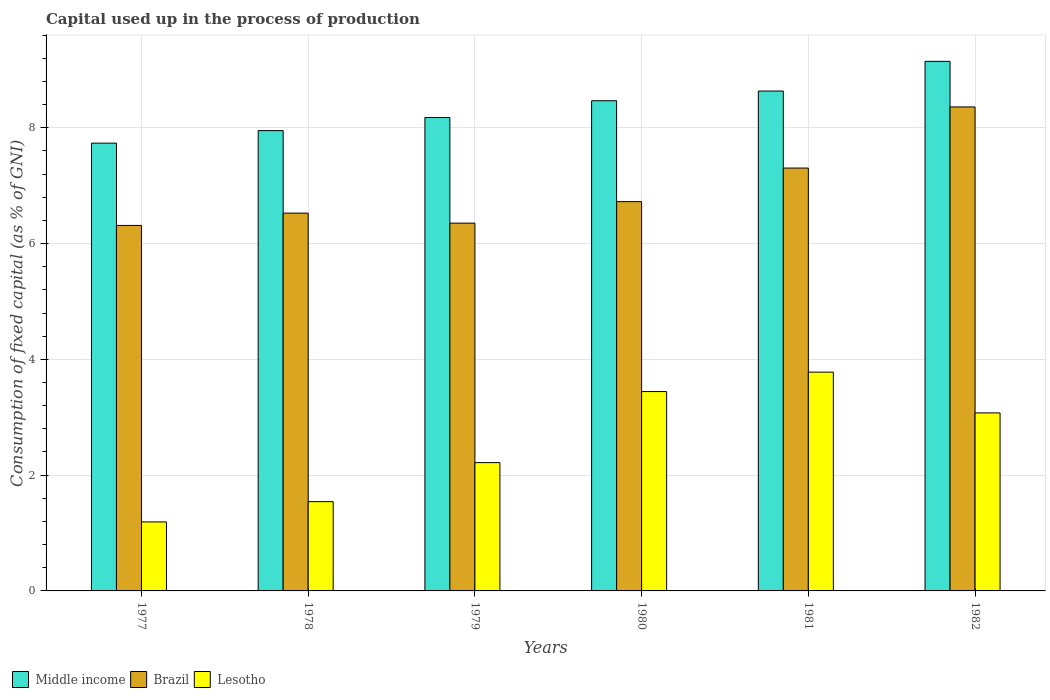How many different coloured bars are there?
Your response must be concise. 3. Are the number of bars per tick equal to the number of legend labels?
Ensure brevity in your answer.  Yes. How many bars are there on the 3rd tick from the right?
Offer a very short reply. 3. What is the label of the 1st group of bars from the left?
Give a very brief answer. 1977. What is the capital used up in the process of production in Lesotho in 1978?
Provide a short and direct response. 1.54. Across all years, what is the maximum capital used up in the process of production in Brazil?
Your answer should be very brief. 8.36. Across all years, what is the minimum capital used up in the process of production in Lesotho?
Keep it short and to the point. 1.19. In which year was the capital used up in the process of production in Brazil maximum?
Provide a short and direct response. 1982. In which year was the capital used up in the process of production in Brazil minimum?
Your answer should be very brief. 1977. What is the total capital used up in the process of production in Lesotho in the graph?
Provide a succinct answer. 15.25. What is the difference between the capital used up in the process of production in Middle income in 1977 and that in 1981?
Your answer should be very brief. -0.9. What is the difference between the capital used up in the process of production in Middle income in 1978 and the capital used up in the process of production in Brazil in 1980?
Give a very brief answer. 1.23. What is the average capital used up in the process of production in Brazil per year?
Keep it short and to the point. 6.93. In the year 1982, what is the difference between the capital used up in the process of production in Middle income and capital used up in the process of production in Lesotho?
Ensure brevity in your answer.  6.07. In how many years, is the capital used up in the process of production in Lesotho greater than 0.4 %?
Your response must be concise. 6. What is the ratio of the capital used up in the process of production in Brazil in 1980 to that in 1982?
Provide a short and direct response. 0.8. Is the difference between the capital used up in the process of production in Middle income in 1977 and 1981 greater than the difference between the capital used up in the process of production in Lesotho in 1977 and 1981?
Ensure brevity in your answer.  Yes. What is the difference between the highest and the second highest capital used up in the process of production in Brazil?
Your response must be concise. 1.06. What is the difference between the highest and the lowest capital used up in the process of production in Brazil?
Make the answer very short. 2.05. Is the sum of the capital used up in the process of production in Lesotho in 1977 and 1978 greater than the maximum capital used up in the process of production in Brazil across all years?
Ensure brevity in your answer.  No. What does the 2nd bar from the left in 1978 represents?
Give a very brief answer. Brazil. What does the 2nd bar from the right in 1981 represents?
Your answer should be compact. Brazil. Is it the case that in every year, the sum of the capital used up in the process of production in Brazil and capital used up in the process of production in Middle income is greater than the capital used up in the process of production in Lesotho?
Make the answer very short. Yes. How many bars are there?
Offer a very short reply. 18. Are all the bars in the graph horizontal?
Keep it short and to the point. No. How many years are there in the graph?
Make the answer very short. 6. What is the difference between two consecutive major ticks on the Y-axis?
Offer a terse response. 2. Does the graph contain any zero values?
Your response must be concise. No. Does the graph contain grids?
Your response must be concise. Yes. Where does the legend appear in the graph?
Your response must be concise. Bottom left. What is the title of the graph?
Ensure brevity in your answer.  Capital used up in the process of production. Does "Kuwait" appear as one of the legend labels in the graph?
Provide a succinct answer. No. What is the label or title of the X-axis?
Your answer should be very brief. Years. What is the label or title of the Y-axis?
Provide a succinct answer. Consumption of fixed capital (as % of GNI). What is the Consumption of fixed capital (as % of GNI) of Middle income in 1977?
Make the answer very short. 7.73. What is the Consumption of fixed capital (as % of GNI) in Brazil in 1977?
Offer a very short reply. 6.31. What is the Consumption of fixed capital (as % of GNI) in Lesotho in 1977?
Ensure brevity in your answer.  1.19. What is the Consumption of fixed capital (as % of GNI) in Middle income in 1978?
Your answer should be compact. 7.95. What is the Consumption of fixed capital (as % of GNI) in Brazil in 1978?
Offer a very short reply. 6.53. What is the Consumption of fixed capital (as % of GNI) of Lesotho in 1978?
Your response must be concise. 1.54. What is the Consumption of fixed capital (as % of GNI) in Middle income in 1979?
Make the answer very short. 8.18. What is the Consumption of fixed capital (as % of GNI) of Brazil in 1979?
Your response must be concise. 6.35. What is the Consumption of fixed capital (as % of GNI) in Lesotho in 1979?
Offer a terse response. 2.22. What is the Consumption of fixed capital (as % of GNI) of Middle income in 1980?
Your response must be concise. 8.47. What is the Consumption of fixed capital (as % of GNI) in Brazil in 1980?
Keep it short and to the point. 6.72. What is the Consumption of fixed capital (as % of GNI) of Lesotho in 1980?
Provide a succinct answer. 3.44. What is the Consumption of fixed capital (as % of GNI) of Middle income in 1981?
Offer a terse response. 8.63. What is the Consumption of fixed capital (as % of GNI) in Brazil in 1981?
Offer a very short reply. 7.3. What is the Consumption of fixed capital (as % of GNI) of Lesotho in 1981?
Offer a terse response. 3.78. What is the Consumption of fixed capital (as % of GNI) in Middle income in 1982?
Your answer should be very brief. 9.15. What is the Consumption of fixed capital (as % of GNI) of Brazil in 1982?
Make the answer very short. 8.36. What is the Consumption of fixed capital (as % of GNI) in Lesotho in 1982?
Your answer should be compact. 3.08. Across all years, what is the maximum Consumption of fixed capital (as % of GNI) in Middle income?
Make the answer very short. 9.15. Across all years, what is the maximum Consumption of fixed capital (as % of GNI) in Brazil?
Provide a succinct answer. 8.36. Across all years, what is the maximum Consumption of fixed capital (as % of GNI) in Lesotho?
Your response must be concise. 3.78. Across all years, what is the minimum Consumption of fixed capital (as % of GNI) in Middle income?
Provide a succinct answer. 7.73. Across all years, what is the minimum Consumption of fixed capital (as % of GNI) in Brazil?
Your answer should be compact. 6.31. Across all years, what is the minimum Consumption of fixed capital (as % of GNI) of Lesotho?
Keep it short and to the point. 1.19. What is the total Consumption of fixed capital (as % of GNI) in Middle income in the graph?
Offer a very short reply. 50.11. What is the total Consumption of fixed capital (as % of GNI) of Brazil in the graph?
Offer a terse response. 41.58. What is the total Consumption of fixed capital (as % of GNI) of Lesotho in the graph?
Make the answer very short. 15.25. What is the difference between the Consumption of fixed capital (as % of GNI) of Middle income in 1977 and that in 1978?
Offer a very short reply. -0.22. What is the difference between the Consumption of fixed capital (as % of GNI) of Brazil in 1977 and that in 1978?
Make the answer very short. -0.21. What is the difference between the Consumption of fixed capital (as % of GNI) in Lesotho in 1977 and that in 1978?
Your answer should be compact. -0.35. What is the difference between the Consumption of fixed capital (as % of GNI) of Middle income in 1977 and that in 1979?
Your answer should be compact. -0.44. What is the difference between the Consumption of fixed capital (as % of GNI) of Brazil in 1977 and that in 1979?
Your answer should be very brief. -0.04. What is the difference between the Consumption of fixed capital (as % of GNI) in Lesotho in 1977 and that in 1979?
Your answer should be very brief. -1.02. What is the difference between the Consumption of fixed capital (as % of GNI) in Middle income in 1977 and that in 1980?
Make the answer very short. -0.73. What is the difference between the Consumption of fixed capital (as % of GNI) in Brazil in 1977 and that in 1980?
Make the answer very short. -0.41. What is the difference between the Consumption of fixed capital (as % of GNI) in Lesotho in 1977 and that in 1980?
Give a very brief answer. -2.25. What is the difference between the Consumption of fixed capital (as % of GNI) in Brazil in 1977 and that in 1981?
Offer a terse response. -0.99. What is the difference between the Consumption of fixed capital (as % of GNI) in Lesotho in 1977 and that in 1981?
Your answer should be compact. -2.59. What is the difference between the Consumption of fixed capital (as % of GNI) in Middle income in 1977 and that in 1982?
Offer a terse response. -1.41. What is the difference between the Consumption of fixed capital (as % of GNI) in Brazil in 1977 and that in 1982?
Offer a very short reply. -2.05. What is the difference between the Consumption of fixed capital (as % of GNI) in Lesotho in 1977 and that in 1982?
Your answer should be very brief. -1.88. What is the difference between the Consumption of fixed capital (as % of GNI) of Middle income in 1978 and that in 1979?
Provide a short and direct response. -0.23. What is the difference between the Consumption of fixed capital (as % of GNI) in Brazil in 1978 and that in 1979?
Your response must be concise. 0.17. What is the difference between the Consumption of fixed capital (as % of GNI) of Lesotho in 1978 and that in 1979?
Offer a terse response. -0.67. What is the difference between the Consumption of fixed capital (as % of GNI) of Middle income in 1978 and that in 1980?
Your response must be concise. -0.52. What is the difference between the Consumption of fixed capital (as % of GNI) in Brazil in 1978 and that in 1980?
Keep it short and to the point. -0.2. What is the difference between the Consumption of fixed capital (as % of GNI) of Lesotho in 1978 and that in 1980?
Offer a very short reply. -1.9. What is the difference between the Consumption of fixed capital (as % of GNI) of Middle income in 1978 and that in 1981?
Ensure brevity in your answer.  -0.68. What is the difference between the Consumption of fixed capital (as % of GNI) in Brazil in 1978 and that in 1981?
Offer a very short reply. -0.78. What is the difference between the Consumption of fixed capital (as % of GNI) of Lesotho in 1978 and that in 1981?
Your response must be concise. -2.24. What is the difference between the Consumption of fixed capital (as % of GNI) of Middle income in 1978 and that in 1982?
Your answer should be compact. -1.2. What is the difference between the Consumption of fixed capital (as % of GNI) of Brazil in 1978 and that in 1982?
Provide a short and direct response. -1.83. What is the difference between the Consumption of fixed capital (as % of GNI) of Lesotho in 1978 and that in 1982?
Your answer should be compact. -1.53. What is the difference between the Consumption of fixed capital (as % of GNI) in Middle income in 1979 and that in 1980?
Your answer should be compact. -0.29. What is the difference between the Consumption of fixed capital (as % of GNI) of Brazil in 1979 and that in 1980?
Ensure brevity in your answer.  -0.37. What is the difference between the Consumption of fixed capital (as % of GNI) of Lesotho in 1979 and that in 1980?
Offer a terse response. -1.23. What is the difference between the Consumption of fixed capital (as % of GNI) of Middle income in 1979 and that in 1981?
Make the answer very short. -0.46. What is the difference between the Consumption of fixed capital (as % of GNI) of Brazil in 1979 and that in 1981?
Keep it short and to the point. -0.95. What is the difference between the Consumption of fixed capital (as % of GNI) in Lesotho in 1979 and that in 1981?
Provide a short and direct response. -1.56. What is the difference between the Consumption of fixed capital (as % of GNI) of Middle income in 1979 and that in 1982?
Your response must be concise. -0.97. What is the difference between the Consumption of fixed capital (as % of GNI) of Brazil in 1979 and that in 1982?
Provide a succinct answer. -2.01. What is the difference between the Consumption of fixed capital (as % of GNI) in Lesotho in 1979 and that in 1982?
Provide a succinct answer. -0.86. What is the difference between the Consumption of fixed capital (as % of GNI) of Middle income in 1980 and that in 1981?
Your answer should be compact. -0.17. What is the difference between the Consumption of fixed capital (as % of GNI) of Brazil in 1980 and that in 1981?
Offer a very short reply. -0.58. What is the difference between the Consumption of fixed capital (as % of GNI) in Lesotho in 1980 and that in 1981?
Give a very brief answer. -0.34. What is the difference between the Consumption of fixed capital (as % of GNI) of Middle income in 1980 and that in 1982?
Your answer should be very brief. -0.68. What is the difference between the Consumption of fixed capital (as % of GNI) in Brazil in 1980 and that in 1982?
Your answer should be very brief. -1.64. What is the difference between the Consumption of fixed capital (as % of GNI) in Lesotho in 1980 and that in 1982?
Provide a short and direct response. 0.37. What is the difference between the Consumption of fixed capital (as % of GNI) in Middle income in 1981 and that in 1982?
Offer a terse response. -0.51. What is the difference between the Consumption of fixed capital (as % of GNI) of Brazil in 1981 and that in 1982?
Your answer should be very brief. -1.06. What is the difference between the Consumption of fixed capital (as % of GNI) of Lesotho in 1981 and that in 1982?
Offer a very short reply. 0.7. What is the difference between the Consumption of fixed capital (as % of GNI) of Middle income in 1977 and the Consumption of fixed capital (as % of GNI) of Brazil in 1978?
Your answer should be compact. 1.21. What is the difference between the Consumption of fixed capital (as % of GNI) in Middle income in 1977 and the Consumption of fixed capital (as % of GNI) in Lesotho in 1978?
Provide a succinct answer. 6.19. What is the difference between the Consumption of fixed capital (as % of GNI) in Brazil in 1977 and the Consumption of fixed capital (as % of GNI) in Lesotho in 1978?
Offer a very short reply. 4.77. What is the difference between the Consumption of fixed capital (as % of GNI) of Middle income in 1977 and the Consumption of fixed capital (as % of GNI) of Brazil in 1979?
Offer a terse response. 1.38. What is the difference between the Consumption of fixed capital (as % of GNI) of Middle income in 1977 and the Consumption of fixed capital (as % of GNI) of Lesotho in 1979?
Provide a short and direct response. 5.52. What is the difference between the Consumption of fixed capital (as % of GNI) of Brazil in 1977 and the Consumption of fixed capital (as % of GNI) of Lesotho in 1979?
Ensure brevity in your answer.  4.1. What is the difference between the Consumption of fixed capital (as % of GNI) in Middle income in 1977 and the Consumption of fixed capital (as % of GNI) in Brazil in 1980?
Your answer should be compact. 1.01. What is the difference between the Consumption of fixed capital (as % of GNI) in Middle income in 1977 and the Consumption of fixed capital (as % of GNI) in Lesotho in 1980?
Provide a short and direct response. 4.29. What is the difference between the Consumption of fixed capital (as % of GNI) of Brazil in 1977 and the Consumption of fixed capital (as % of GNI) of Lesotho in 1980?
Provide a short and direct response. 2.87. What is the difference between the Consumption of fixed capital (as % of GNI) of Middle income in 1977 and the Consumption of fixed capital (as % of GNI) of Brazil in 1981?
Your answer should be very brief. 0.43. What is the difference between the Consumption of fixed capital (as % of GNI) of Middle income in 1977 and the Consumption of fixed capital (as % of GNI) of Lesotho in 1981?
Offer a very short reply. 3.96. What is the difference between the Consumption of fixed capital (as % of GNI) in Brazil in 1977 and the Consumption of fixed capital (as % of GNI) in Lesotho in 1981?
Give a very brief answer. 2.53. What is the difference between the Consumption of fixed capital (as % of GNI) in Middle income in 1977 and the Consumption of fixed capital (as % of GNI) in Brazil in 1982?
Provide a succinct answer. -0.63. What is the difference between the Consumption of fixed capital (as % of GNI) in Middle income in 1977 and the Consumption of fixed capital (as % of GNI) in Lesotho in 1982?
Provide a short and direct response. 4.66. What is the difference between the Consumption of fixed capital (as % of GNI) in Brazil in 1977 and the Consumption of fixed capital (as % of GNI) in Lesotho in 1982?
Provide a succinct answer. 3.24. What is the difference between the Consumption of fixed capital (as % of GNI) in Middle income in 1978 and the Consumption of fixed capital (as % of GNI) in Brazil in 1979?
Provide a short and direct response. 1.6. What is the difference between the Consumption of fixed capital (as % of GNI) in Middle income in 1978 and the Consumption of fixed capital (as % of GNI) in Lesotho in 1979?
Give a very brief answer. 5.74. What is the difference between the Consumption of fixed capital (as % of GNI) in Brazil in 1978 and the Consumption of fixed capital (as % of GNI) in Lesotho in 1979?
Your answer should be very brief. 4.31. What is the difference between the Consumption of fixed capital (as % of GNI) in Middle income in 1978 and the Consumption of fixed capital (as % of GNI) in Brazil in 1980?
Provide a short and direct response. 1.23. What is the difference between the Consumption of fixed capital (as % of GNI) of Middle income in 1978 and the Consumption of fixed capital (as % of GNI) of Lesotho in 1980?
Offer a terse response. 4.51. What is the difference between the Consumption of fixed capital (as % of GNI) of Brazil in 1978 and the Consumption of fixed capital (as % of GNI) of Lesotho in 1980?
Keep it short and to the point. 3.08. What is the difference between the Consumption of fixed capital (as % of GNI) in Middle income in 1978 and the Consumption of fixed capital (as % of GNI) in Brazil in 1981?
Offer a terse response. 0.65. What is the difference between the Consumption of fixed capital (as % of GNI) in Middle income in 1978 and the Consumption of fixed capital (as % of GNI) in Lesotho in 1981?
Your answer should be very brief. 4.17. What is the difference between the Consumption of fixed capital (as % of GNI) of Brazil in 1978 and the Consumption of fixed capital (as % of GNI) of Lesotho in 1981?
Offer a terse response. 2.75. What is the difference between the Consumption of fixed capital (as % of GNI) in Middle income in 1978 and the Consumption of fixed capital (as % of GNI) in Brazil in 1982?
Make the answer very short. -0.41. What is the difference between the Consumption of fixed capital (as % of GNI) in Middle income in 1978 and the Consumption of fixed capital (as % of GNI) in Lesotho in 1982?
Ensure brevity in your answer.  4.88. What is the difference between the Consumption of fixed capital (as % of GNI) of Brazil in 1978 and the Consumption of fixed capital (as % of GNI) of Lesotho in 1982?
Your answer should be compact. 3.45. What is the difference between the Consumption of fixed capital (as % of GNI) in Middle income in 1979 and the Consumption of fixed capital (as % of GNI) in Brazil in 1980?
Give a very brief answer. 1.45. What is the difference between the Consumption of fixed capital (as % of GNI) of Middle income in 1979 and the Consumption of fixed capital (as % of GNI) of Lesotho in 1980?
Offer a terse response. 4.73. What is the difference between the Consumption of fixed capital (as % of GNI) of Brazil in 1979 and the Consumption of fixed capital (as % of GNI) of Lesotho in 1980?
Offer a very short reply. 2.91. What is the difference between the Consumption of fixed capital (as % of GNI) in Middle income in 1979 and the Consumption of fixed capital (as % of GNI) in Brazil in 1981?
Provide a succinct answer. 0.87. What is the difference between the Consumption of fixed capital (as % of GNI) in Middle income in 1979 and the Consumption of fixed capital (as % of GNI) in Lesotho in 1981?
Provide a succinct answer. 4.4. What is the difference between the Consumption of fixed capital (as % of GNI) of Brazil in 1979 and the Consumption of fixed capital (as % of GNI) of Lesotho in 1981?
Provide a short and direct response. 2.57. What is the difference between the Consumption of fixed capital (as % of GNI) of Middle income in 1979 and the Consumption of fixed capital (as % of GNI) of Brazil in 1982?
Keep it short and to the point. -0.18. What is the difference between the Consumption of fixed capital (as % of GNI) in Middle income in 1979 and the Consumption of fixed capital (as % of GNI) in Lesotho in 1982?
Provide a short and direct response. 5.1. What is the difference between the Consumption of fixed capital (as % of GNI) of Brazil in 1979 and the Consumption of fixed capital (as % of GNI) of Lesotho in 1982?
Provide a succinct answer. 3.28. What is the difference between the Consumption of fixed capital (as % of GNI) in Middle income in 1980 and the Consumption of fixed capital (as % of GNI) in Brazil in 1981?
Keep it short and to the point. 1.16. What is the difference between the Consumption of fixed capital (as % of GNI) of Middle income in 1980 and the Consumption of fixed capital (as % of GNI) of Lesotho in 1981?
Offer a very short reply. 4.69. What is the difference between the Consumption of fixed capital (as % of GNI) of Brazil in 1980 and the Consumption of fixed capital (as % of GNI) of Lesotho in 1981?
Provide a short and direct response. 2.95. What is the difference between the Consumption of fixed capital (as % of GNI) of Middle income in 1980 and the Consumption of fixed capital (as % of GNI) of Brazil in 1982?
Your answer should be very brief. 0.11. What is the difference between the Consumption of fixed capital (as % of GNI) in Middle income in 1980 and the Consumption of fixed capital (as % of GNI) in Lesotho in 1982?
Provide a short and direct response. 5.39. What is the difference between the Consumption of fixed capital (as % of GNI) of Brazil in 1980 and the Consumption of fixed capital (as % of GNI) of Lesotho in 1982?
Your answer should be very brief. 3.65. What is the difference between the Consumption of fixed capital (as % of GNI) of Middle income in 1981 and the Consumption of fixed capital (as % of GNI) of Brazil in 1982?
Your response must be concise. 0.27. What is the difference between the Consumption of fixed capital (as % of GNI) of Middle income in 1981 and the Consumption of fixed capital (as % of GNI) of Lesotho in 1982?
Provide a succinct answer. 5.56. What is the difference between the Consumption of fixed capital (as % of GNI) of Brazil in 1981 and the Consumption of fixed capital (as % of GNI) of Lesotho in 1982?
Provide a short and direct response. 4.23. What is the average Consumption of fixed capital (as % of GNI) of Middle income per year?
Ensure brevity in your answer.  8.35. What is the average Consumption of fixed capital (as % of GNI) in Brazil per year?
Provide a succinct answer. 6.93. What is the average Consumption of fixed capital (as % of GNI) of Lesotho per year?
Your answer should be very brief. 2.54. In the year 1977, what is the difference between the Consumption of fixed capital (as % of GNI) in Middle income and Consumption of fixed capital (as % of GNI) in Brazil?
Keep it short and to the point. 1.42. In the year 1977, what is the difference between the Consumption of fixed capital (as % of GNI) in Middle income and Consumption of fixed capital (as % of GNI) in Lesotho?
Offer a very short reply. 6.54. In the year 1977, what is the difference between the Consumption of fixed capital (as % of GNI) in Brazil and Consumption of fixed capital (as % of GNI) in Lesotho?
Make the answer very short. 5.12. In the year 1978, what is the difference between the Consumption of fixed capital (as % of GNI) in Middle income and Consumption of fixed capital (as % of GNI) in Brazil?
Provide a short and direct response. 1.43. In the year 1978, what is the difference between the Consumption of fixed capital (as % of GNI) in Middle income and Consumption of fixed capital (as % of GNI) in Lesotho?
Your answer should be compact. 6.41. In the year 1978, what is the difference between the Consumption of fixed capital (as % of GNI) of Brazil and Consumption of fixed capital (as % of GNI) of Lesotho?
Offer a terse response. 4.98. In the year 1979, what is the difference between the Consumption of fixed capital (as % of GNI) in Middle income and Consumption of fixed capital (as % of GNI) in Brazil?
Your answer should be very brief. 1.82. In the year 1979, what is the difference between the Consumption of fixed capital (as % of GNI) in Middle income and Consumption of fixed capital (as % of GNI) in Lesotho?
Keep it short and to the point. 5.96. In the year 1979, what is the difference between the Consumption of fixed capital (as % of GNI) of Brazil and Consumption of fixed capital (as % of GNI) of Lesotho?
Provide a short and direct response. 4.14. In the year 1980, what is the difference between the Consumption of fixed capital (as % of GNI) of Middle income and Consumption of fixed capital (as % of GNI) of Brazil?
Your answer should be compact. 1.74. In the year 1980, what is the difference between the Consumption of fixed capital (as % of GNI) in Middle income and Consumption of fixed capital (as % of GNI) in Lesotho?
Your response must be concise. 5.02. In the year 1980, what is the difference between the Consumption of fixed capital (as % of GNI) in Brazil and Consumption of fixed capital (as % of GNI) in Lesotho?
Ensure brevity in your answer.  3.28. In the year 1981, what is the difference between the Consumption of fixed capital (as % of GNI) in Middle income and Consumption of fixed capital (as % of GNI) in Brazil?
Give a very brief answer. 1.33. In the year 1981, what is the difference between the Consumption of fixed capital (as % of GNI) of Middle income and Consumption of fixed capital (as % of GNI) of Lesotho?
Provide a succinct answer. 4.86. In the year 1981, what is the difference between the Consumption of fixed capital (as % of GNI) of Brazil and Consumption of fixed capital (as % of GNI) of Lesotho?
Your response must be concise. 3.53. In the year 1982, what is the difference between the Consumption of fixed capital (as % of GNI) in Middle income and Consumption of fixed capital (as % of GNI) in Brazil?
Keep it short and to the point. 0.79. In the year 1982, what is the difference between the Consumption of fixed capital (as % of GNI) in Middle income and Consumption of fixed capital (as % of GNI) in Lesotho?
Offer a very short reply. 6.07. In the year 1982, what is the difference between the Consumption of fixed capital (as % of GNI) in Brazil and Consumption of fixed capital (as % of GNI) in Lesotho?
Provide a succinct answer. 5.29. What is the ratio of the Consumption of fixed capital (as % of GNI) in Middle income in 1977 to that in 1978?
Your answer should be very brief. 0.97. What is the ratio of the Consumption of fixed capital (as % of GNI) in Brazil in 1977 to that in 1978?
Your response must be concise. 0.97. What is the ratio of the Consumption of fixed capital (as % of GNI) in Lesotho in 1977 to that in 1978?
Your answer should be very brief. 0.77. What is the ratio of the Consumption of fixed capital (as % of GNI) of Middle income in 1977 to that in 1979?
Offer a terse response. 0.95. What is the ratio of the Consumption of fixed capital (as % of GNI) of Brazil in 1977 to that in 1979?
Provide a short and direct response. 0.99. What is the ratio of the Consumption of fixed capital (as % of GNI) of Lesotho in 1977 to that in 1979?
Offer a terse response. 0.54. What is the ratio of the Consumption of fixed capital (as % of GNI) in Middle income in 1977 to that in 1980?
Ensure brevity in your answer.  0.91. What is the ratio of the Consumption of fixed capital (as % of GNI) of Brazil in 1977 to that in 1980?
Offer a terse response. 0.94. What is the ratio of the Consumption of fixed capital (as % of GNI) in Lesotho in 1977 to that in 1980?
Provide a succinct answer. 0.35. What is the ratio of the Consumption of fixed capital (as % of GNI) in Middle income in 1977 to that in 1981?
Keep it short and to the point. 0.9. What is the ratio of the Consumption of fixed capital (as % of GNI) in Brazil in 1977 to that in 1981?
Your response must be concise. 0.86. What is the ratio of the Consumption of fixed capital (as % of GNI) in Lesotho in 1977 to that in 1981?
Give a very brief answer. 0.32. What is the ratio of the Consumption of fixed capital (as % of GNI) in Middle income in 1977 to that in 1982?
Give a very brief answer. 0.85. What is the ratio of the Consumption of fixed capital (as % of GNI) of Brazil in 1977 to that in 1982?
Make the answer very short. 0.76. What is the ratio of the Consumption of fixed capital (as % of GNI) of Lesotho in 1977 to that in 1982?
Make the answer very short. 0.39. What is the ratio of the Consumption of fixed capital (as % of GNI) of Middle income in 1978 to that in 1979?
Ensure brevity in your answer.  0.97. What is the ratio of the Consumption of fixed capital (as % of GNI) of Brazil in 1978 to that in 1979?
Provide a short and direct response. 1.03. What is the ratio of the Consumption of fixed capital (as % of GNI) in Lesotho in 1978 to that in 1979?
Give a very brief answer. 0.7. What is the ratio of the Consumption of fixed capital (as % of GNI) in Middle income in 1978 to that in 1980?
Your answer should be compact. 0.94. What is the ratio of the Consumption of fixed capital (as % of GNI) of Brazil in 1978 to that in 1980?
Offer a very short reply. 0.97. What is the ratio of the Consumption of fixed capital (as % of GNI) of Lesotho in 1978 to that in 1980?
Provide a succinct answer. 0.45. What is the ratio of the Consumption of fixed capital (as % of GNI) of Middle income in 1978 to that in 1981?
Give a very brief answer. 0.92. What is the ratio of the Consumption of fixed capital (as % of GNI) of Brazil in 1978 to that in 1981?
Provide a short and direct response. 0.89. What is the ratio of the Consumption of fixed capital (as % of GNI) in Lesotho in 1978 to that in 1981?
Your answer should be very brief. 0.41. What is the ratio of the Consumption of fixed capital (as % of GNI) in Middle income in 1978 to that in 1982?
Ensure brevity in your answer.  0.87. What is the ratio of the Consumption of fixed capital (as % of GNI) of Brazil in 1978 to that in 1982?
Your response must be concise. 0.78. What is the ratio of the Consumption of fixed capital (as % of GNI) of Lesotho in 1978 to that in 1982?
Make the answer very short. 0.5. What is the ratio of the Consumption of fixed capital (as % of GNI) of Middle income in 1979 to that in 1980?
Offer a terse response. 0.97. What is the ratio of the Consumption of fixed capital (as % of GNI) in Brazil in 1979 to that in 1980?
Your response must be concise. 0.94. What is the ratio of the Consumption of fixed capital (as % of GNI) of Lesotho in 1979 to that in 1980?
Make the answer very short. 0.64. What is the ratio of the Consumption of fixed capital (as % of GNI) in Middle income in 1979 to that in 1981?
Ensure brevity in your answer.  0.95. What is the ratio of the Consumption of fixed capital (as % of GNI) of Brazil in 1979 to that in 1981?
Give a very brief answer. 0.87. What is the ratio of the Consumption of fixed capital (as % of GNI) of Lesotho in 1979 to that in 1981?
Offer a very short reply. 0.59. What is the ratio of the Consumption of fixed capital (as % of GNI) of Middle income in 1979 to that in 1982?
Provide a succinct answer. 0.89. What is the ratio of the Consumption of fixed capital (as % of GNI) of Brazil in 1979 to that in 1982?
Give a very brief answer. 0.76. What is the ratio of the Consumption of fixed capital (as % of GNI) in Lesotho in 1979 to that in 1982?
Give a very brief answer. 0.72. What is the ratio of the Consumption of fixed capital (as % of GNI) of Middle income in 1980 to that in 1981?
Your answer should be compact. 0.98. What is the ratio of the Consumption of fixed capital (as % of GNI) of Brazil in 1980 to that in 1981?
Your response must be concise. 0.92. What is the ratio of the Consumption of fixed capital (as % of GNI) in Lesotho in 1980 to that in 1981?
Your answer should be very brief. 0.91. What is the ratio of the Consumption of fixed capital (as % of GNI) of Middle income in 1980 to that in 1982?
Keep it short and to the point. 0.93. What is the ratio of the Consumption of fixed capital (as % of GNI) in Brazil in 1980 to that in 1982?
Your answer should be compact. 0.8. What is the ratio of the Consumption of fixed capital (as % of GNI) of Lesotho in 1980 to that in 1982?
Provide a succinct answer. 1.12. What is the ratio of the Consumption of fixed capital (as % of GNI) of Middle income in 1981 to that in 1982?
Provide a succinct answer. 0.94. What is the ratio of the Consumption of fixed capital (as % of GNI) of Brazil in 1981 to that in 1982?
Provide a short and direct response. 0.87. What is the ratio of the Consumption of fixed capital (as % of GNI) in Lesotho in 1981 to that in 1982?
Keep it short and to the point. 1.23. What is the difference between the highest and the second highest Consumption of fixed capital (as % of GNI) in Middle income?
Offer a very short reply. 0.51. What is the difference between the highest and the second highest Consumption of fixed capital (as % of GNI) of Brazil?
Offer a terse response. 1.06. What is the difference between the highest and the second highest Consumption of fixed capital (as % of GNI) of Lesotho?
Offer a very short reply. 0.34. What is the difference between the highest and the lowest Consumption of fixed capital (as % of GNI) in Middle income?
Provide a short and direct response. 1.41. What is the difference between the highest and the lowest Consumption of fixed capital (as % of GNI) of Brazil?
Give a very brief answer. 2.05. What is the difference between the highest and the lowest Consumption of fixed capital (as % of GNI) in Lesotho?
Provide a succinct answer. 2.59. 